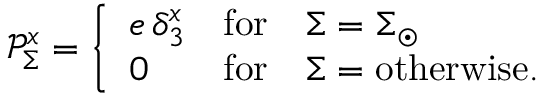<formula> <loc_0><loc_0><loc_500><loc_500>\mathcal { P } _ { \Sigma } ^ { x } = \left \{ \begin{array} { l c l } { { e \, \delta _ { 3 } ^ { x } } } & { f o r } & { { \Sigma = \Sigma _ { \odot } } } \\ { 0 } & { f o r } & { \Sigma = o t h e r w i s e . \ } \end{array}</formula> 